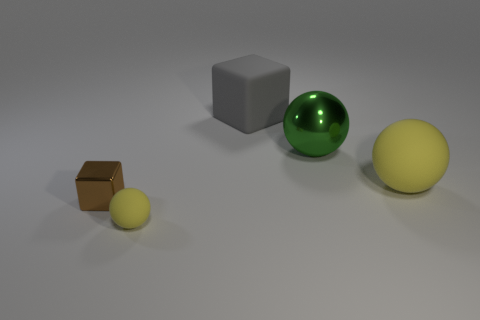Add 3 tiny blocks. How many objects exist? 8 Subtract all cubes. How many objects are left? 3 Add 3 gray objects. How many gray objects exist? 4 Subtract 0 cyan spheres. How many objects are left? 5 Subtract all large balls. Subtract all tiny balls. How many objects are left? 2 Add 2 large yellow rubber objects. How many large yellow rubber objects are left? 3 